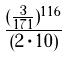Convert formula to latex. <formula><loc_0><loc_0><loc_500><loc_500>\frac { ( \frac { 3 } { 1 7 1 } ) ^ { 1 1 6 } } { ( 2 \cdot 1 0 ) }</formula> 